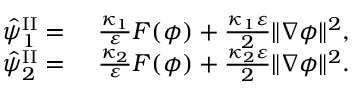<formula> <loc_0><loc_0><loc_500><loc_500>\begin{array} { r l } { \hat { \psi } _ { 1 } ^ { I I } = } & { \frac { \kappa _ { 1 } } { \varepsilon } F ( \phi ) + \frac { \kappa _ { 1 } \varepsilon } { 2 } \| \nabla \phi \| ^ { 2 } , } \\ { \hat { \psi } _ { 2 } ^ { I I } = } & { \frac { \kappa _ { 2 } } { \varepsilon } F ( \phi ) + \frac { \kappa _ { 2 } \varepsilon } { 2 } \| \nabla \phi \| ^ { 2 } . } \end{array}</formula> 